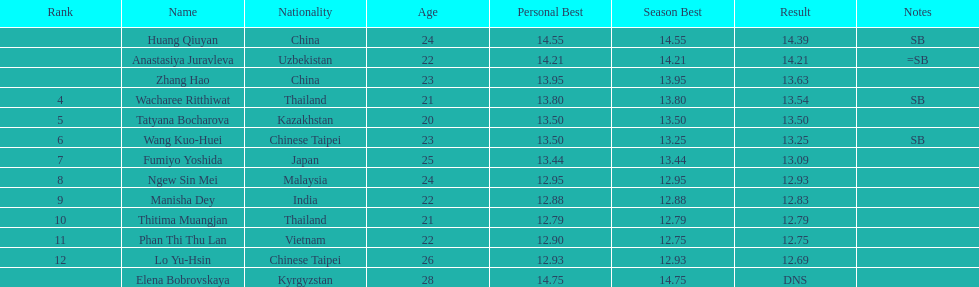Which country came in first? China. 